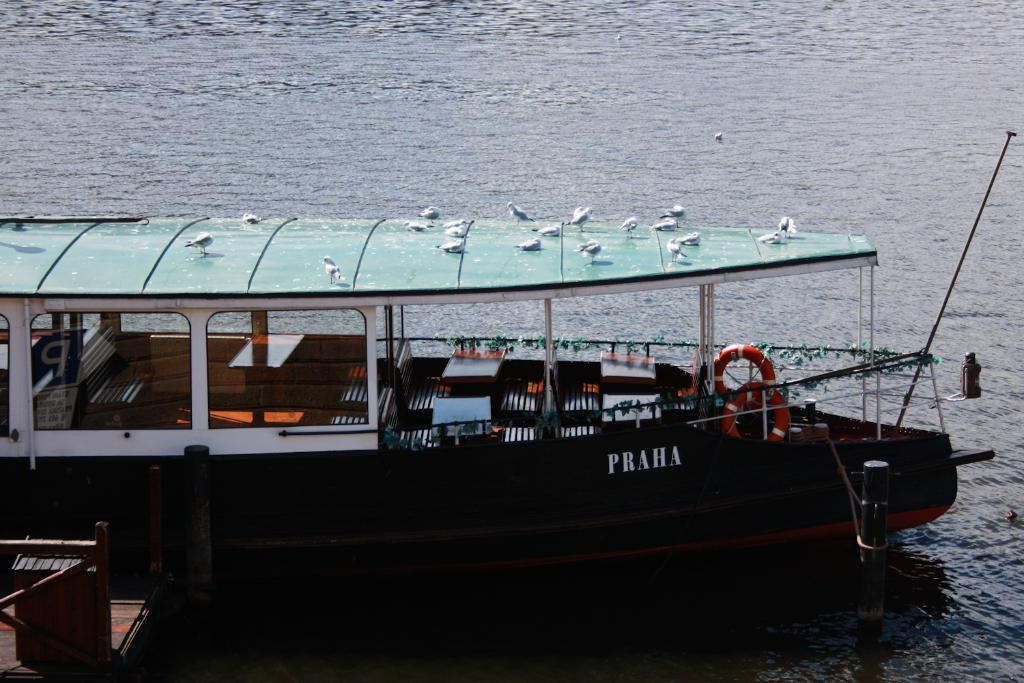What is the main subject in the foreground of the image? There is a boat in the foreground of the image. Are there any living creatures on the boat? Yes, there are birds on the boat. What can be seen in the left bottom corner of the image? There appears to be a dock in the left bottom corner of the image. What is visible at the top of the image? Water is visible at the top of the image. What type of quarter is being used to celebrate the birthday on the boat? There is no mention of a quarter or a birthday in the image, so this question cannot be answered. 